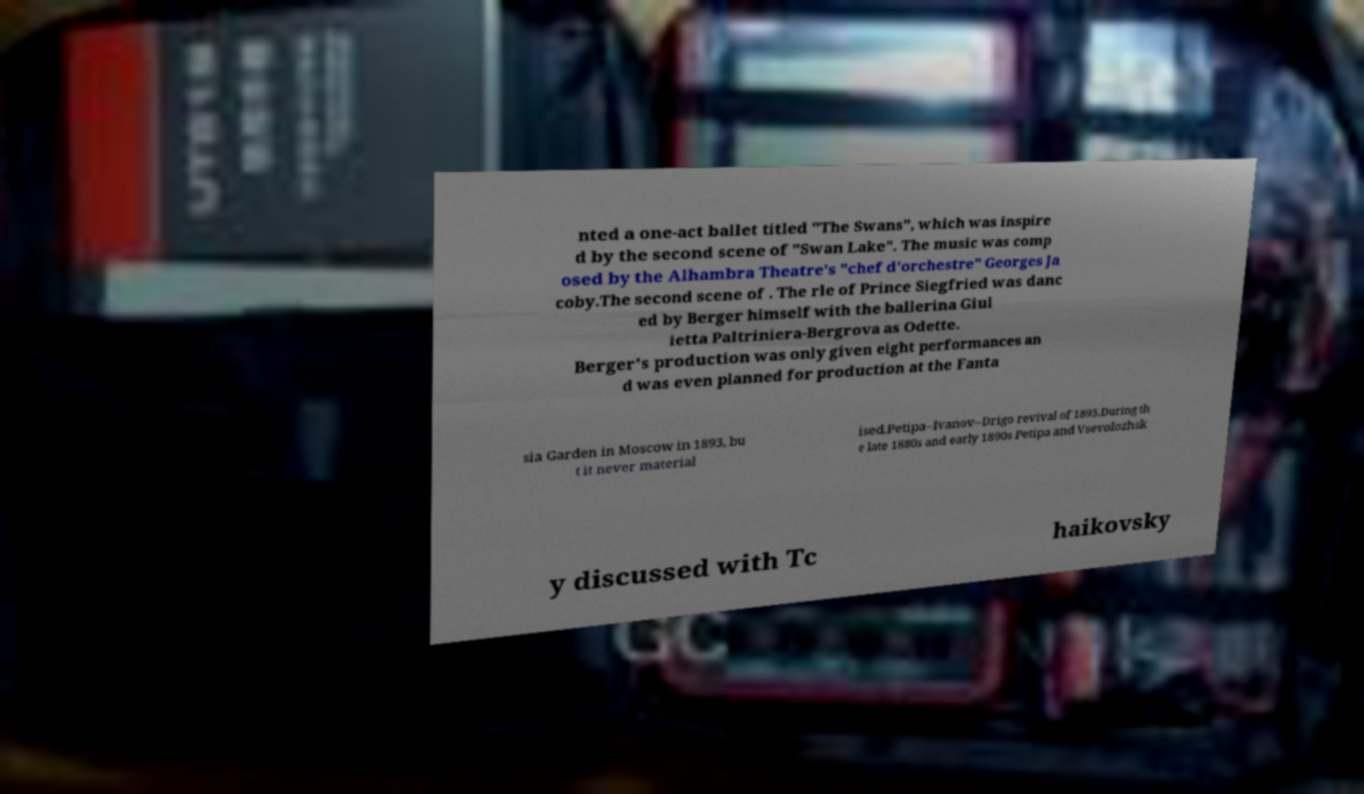Could you assist in decoding the text presented in this image and type it out clearly? nted a one-act ballet titled "The Swans", which was inspire d by the second scene of "Swan Lake". The music was comp osed by the Alhambra Theatre's "chef d'orchestre" Georges Ja coby.The second scene of . The rle of Prince Siegfried was danc ed by Berger himself with the ballerina Giul ietta Paltriniera-Bergrova as Odette. Berger's production was only given eight performances an d was even planned for production at the Fanta sia Garden in Moscow in 1893, bu t it never material ised.Petipa–Ivanov–Drigo revival of 1895.During th e late 1880s and early 1890s Petipa and Vsevolozhsk y discussed with Tc haikovsky 